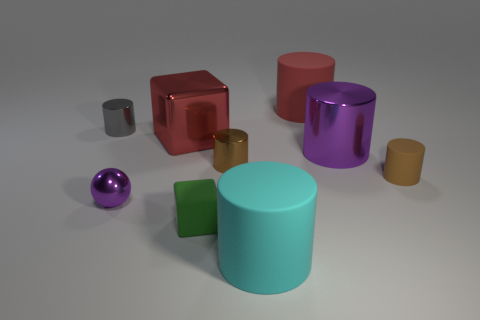Subtract 2 cylinders. How many cylinders are left? 4 Subtract all big rubber cylinders. How many cylinders are left? 4 Subtract all purple cylinders. How many cylinders are left? 5 Subtract all gray cylinders. Subtract all brown cubes. How many cylinders are left? 5 Add 1 tiny purple objects. How many objects exist? 10 Subtract all spheres. How many objects are left? 8 Subtract 1 green cubes. How many objects are left? 8 Subtract all big green rubber balls. Subtract all purple shiny balls. How many objects are left? 8 Add 1 red shiny blocks. How many red shiny blocks are left? 2 Add 1 brown rubber cylinders. How many brown rubber cylinders exist? 2 